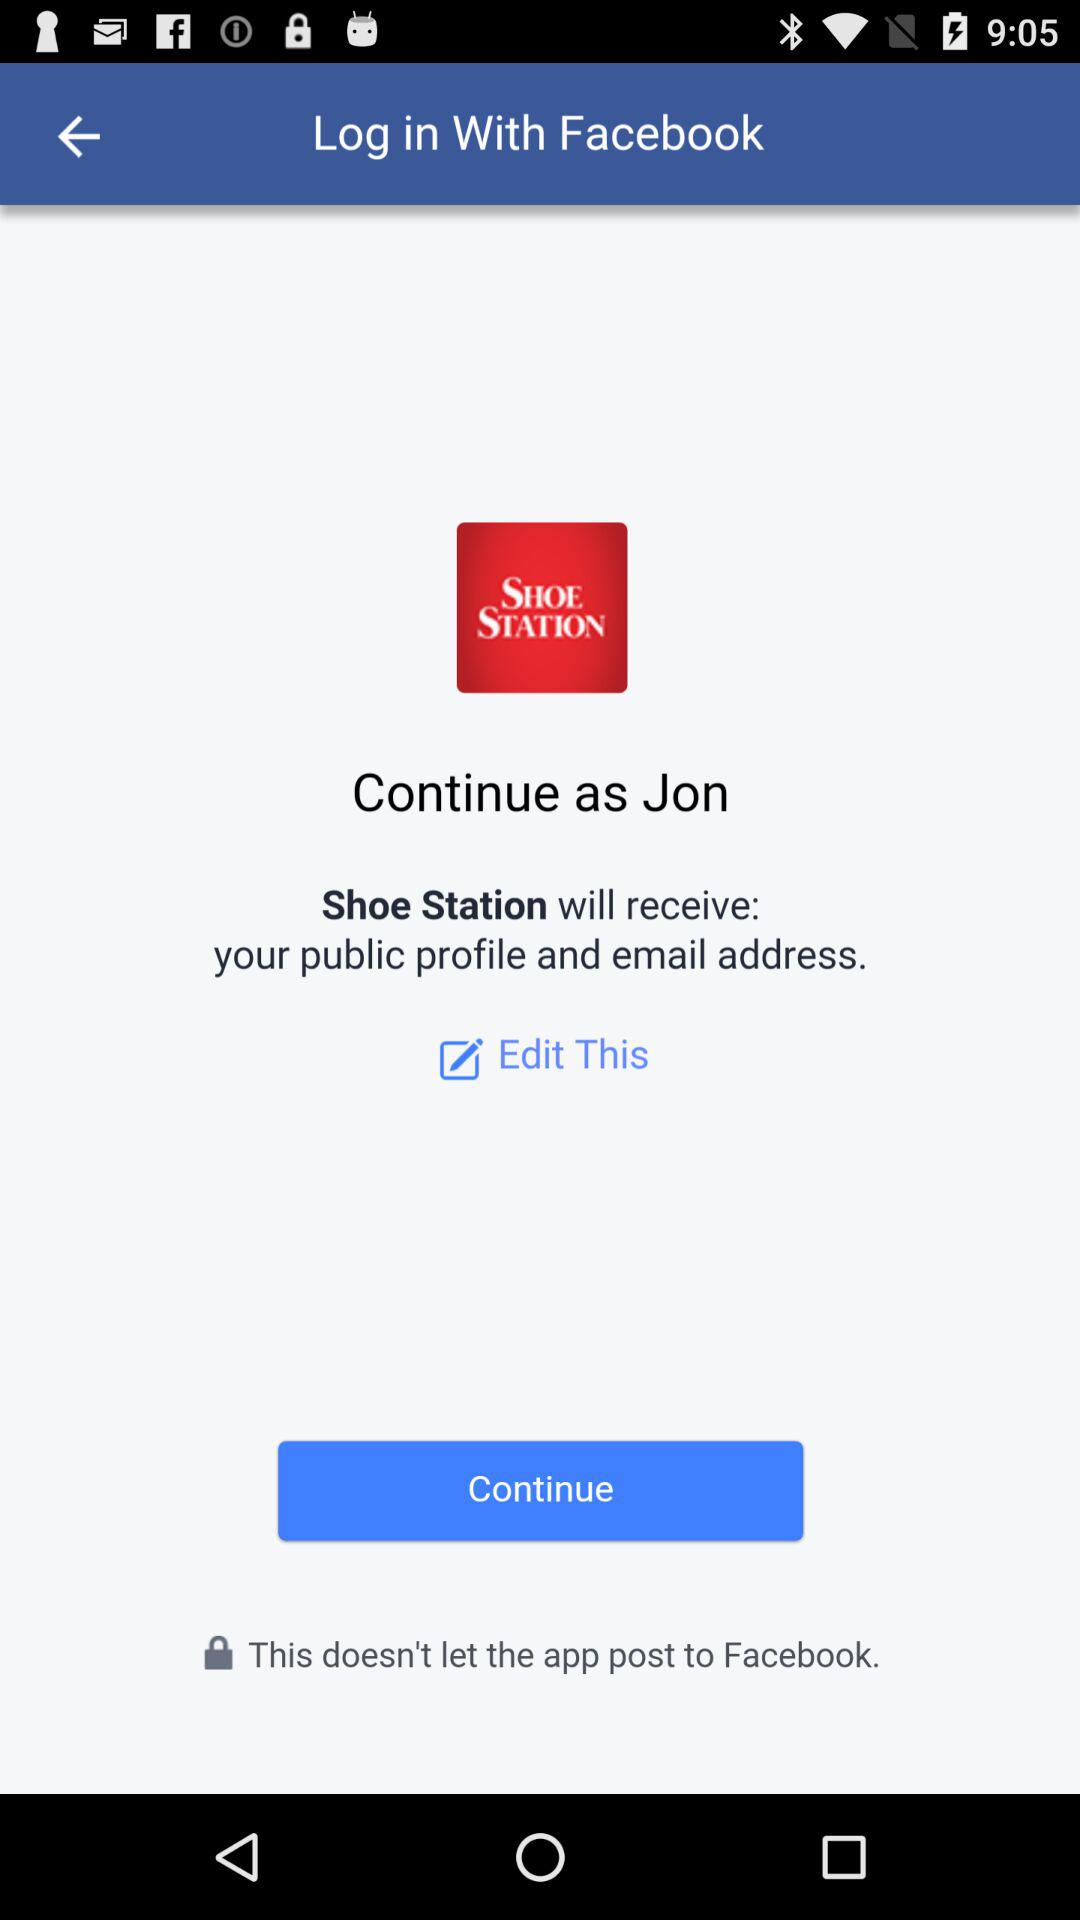What is the name of the user? The name of the user is Jon. 